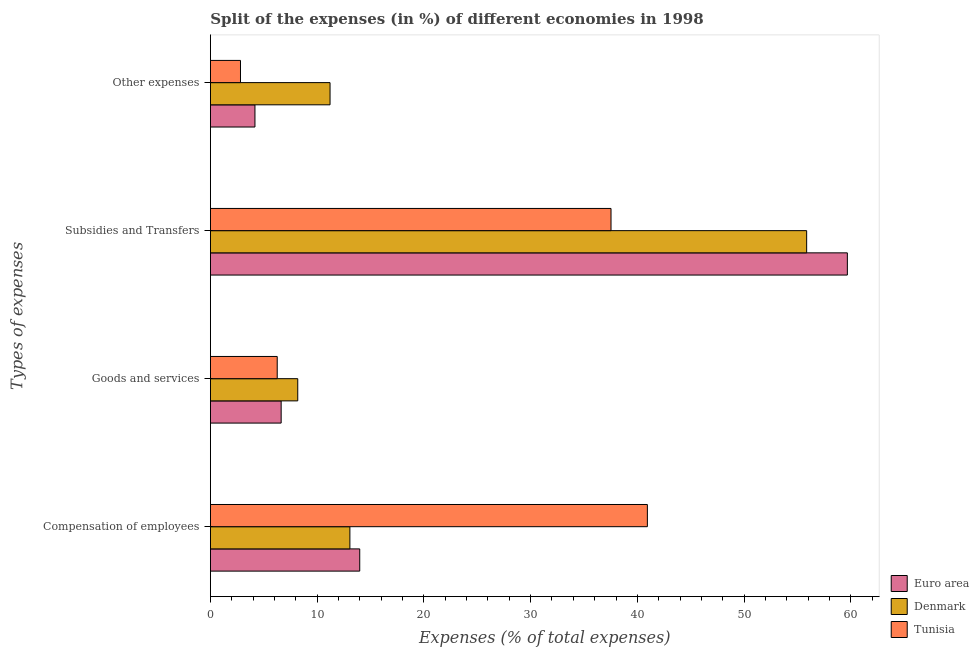How many different coloured bars are there?
Make the answer very short. 3. How many groups of bars are there?
Your answer should be compact. 4. Are the number of bars per tick equal to the number of legend labels?
Provide a short and direct response. Yes. Are the number of bars on each tick of the Y-axis equal?
Your response must be concise. Yes. How many bars are there on the 4th tick from the bottom?
Ensure brevity in your answer.  3. What is the label of the 4th group of bars from the top?
Provide a short and direct response. Compensation of employees. What is the percentage of amount spent on goods and services in Tunisia?
Offer a very short reply. 6.26. Across all countries, what is the maximum percentage of amount spent on subsidies?
Your response must be concise. 59.67. Across all countries, what is the minimum percentage of amount spent on other expenses?
Offer a very short reply. 2.82. In which country was the percentage of amount spent on goods and services maximum?
Your answer should be compact. Denmark. In which country was the percentage of amount spent on goods and services minimum?
Make the answer very short. Tunisia. What is the total percentage of amount spent on other expenses in the graph?
Your answer should be compact. 18.21. What is the difference between the percentage of amount spent on goods and services in Tunisia and that in Euro area?
Your answer should be compact. -0.37. What is the difference between the percentage of amount spent on compensation of employees in Tunisia and the percentage of amount spent on goods and services in Denmark?
Offer a very short reply. 32.75. What is the average percentage of amount spent on goods and services per country?
Make the answer very short. 7.03. What is the difference between the percentage of amount spent on subsidies and percentage of amount spent on goods and services in Tunisia?
Offer a terse response. 31.27. In how many countries, is the percentage of amount spent on goods and services greater than 30 %?
Provide a succinct answer. 0. What is the ratio of the percentage of amount spent on subsidies in Tunisia to that in Denmark?
Offer a very short reply. 0.67. What is the difference between the highest and the second highest percentage of amount spent on subsidies?
Give a very brief answer. 3.81. What is the difference between the highest and the lowest percentage of amount spent on compensation of employees?
Your response must be concise. 27.87. In how many countries, is the percentage of amount spent on compensation of employees greater than the average percentage of amount spent on compensation of employees taken over all countries?
Provide a short and direct response. 1. Is the sum of the percentage of amount spent on goods and services in Tunisia and Euro area greater than the maximum percentage of amount spent on subsidies across all countries?
Offer a terse response. No. What does the 1st bar from the top in Subsidies and Transfers represents?
Give a very brief answer. Tunisia. What does the 1st bar from the bottom in Goods and services represents?
Ensure brevity in your answer.  Euro area. Are all the bars in the graph horizontal?
Keep it short and to the point. Yes. Are the values on the major ticks of X-axis written in scientific E-notation?
Your answer should be compact. No. Where does the legend appear in the graph?
Offer a very short reply. Bottom right. How many legend labels are there?
Provide a short and direct response. 3. What is the title of the graph?
Offer a terse response. Split of the expenses (in %) of different economies in 1998. Does "Malawi" appear as one of the legend labels in the graph?
Provide a short and direct response. No. What is the label or title of the X-axis?
Give a very brief answer. Expenses (% of total expenses). What is the label or title of the Y-axis?
Give a very brief answer. Types of expenses. What is the Expenses (% of total expenses) of Euro area in Compensation of employees?
Ensure brevity in your answer.  13.99. What is the Expenses (% of total expenses) of Denmark in Compensation of employees?
Provide a short and direct response. 13.07. What is the Expenses (% of total expenses) in Tunisia in Compensation of employees?
Offer a very short reply. 40.94. What is the Expenses (% of total expenses) of Euro area in Goods and services?
Provide a succinct answer. 6.63. What is the Expenses (% of total expenses) in Denmark in Goods and services?
Provide a succinct answer. 8.18. What is the Expenses (% of total expenses) of Tunisia in Goods and services?
Your response must be concise. 6.26. What is the Expenses (% of total expenses) of Euro area in Subsidies and Transfers?
Your answer should be very brief. 59.67. What is the Expenses (% of total expenses) of Denmark in Subsidies and Transfers?
Your answer should be very brief. 55.86. What is the Expenses (% of total expenses) of Tunisia in Subsidies and Transfers?
Ensure brevity in your answer.  37.53. What is the Expenses (% of total expenses) in Euro area in Other expenses?
Make the answer very short. 4.18. What is the Expenses (% of total expenses) in Denmark in Other expenses?
Your response must be concise. 11.21. What is the Expenses (% of total expenses) in Tunisia in Other expenses?
Your response must be concise. 2.82. Across all Types of expenses, what is the maximum Expenses (% of total expenses) in Euro area?
Keep it short and to the point. 59.67. Across all Types of expenses, what is the maximum Expenses (% of total expenses) in Denmark?
Give a very brief answer. 55.86. Across all Types of expenses, what is the maximum Expenses (% of total expenses) in Tunisia?
Ensure brevity in your answer.  40.94. Across all Types of expenses, what is the minimum Expenses (% of total expenses) in Euro area?
Ensure brevity in your answer.  4.18. Across all Types of expenses, what is the minimum Expenses (% of total expenses) in Denmark?
Keep it short and to the point. 8.18. Across all Types of expenses, what is the minimum Expenses (% of total expenses) in Tunisia?
Provide a succinct answer. 2.82. What is the total Expenses (% of total expenses) in Euro area in the graph?
Keep it short and to the point. 84.47. What is the total Expenses (% of total expenses) in Denmark in the graph?
Give a very brief answer. 88.32. What is the total Expenses (% of total expenses) in Tunisia in the graph?
Your answer should be compact. 87.55. What is the difference between the Expenses (% of total expenses) in Euro area in Compensation of employees and that in Goods and services?
Provide a short and direct response. 7.36. What is the difference between the Expenses (% of total expenses) in Denmark in Compensation of employees and that in Goods and services?
Your response must be concise. 4.88. What is the difference between the Expenses (% of total expenses) in Tunisia in Compensation of employees and that in Goods and services?
Offer a terse response. 34.68. What is the difference between the Expenses (% of total expenses) of Euro area in Compensation of employees and that in Subsidies and Transfers?
Provide a short and direct response. -45.68. What is the difference between the Expenses (% of total expenses) in Denmark in Compensation of employees and that in Subsidies and Transfers?
Your answer should be very brief. -42.79. What is the difference between the Expenses (% of total expenses) of Tunisia in Compensation of employees and that in Subsidies and Transfers?
Keep it short and to the point. 3.41. What is the difference between the Expenses (% of total expenses) in Euro area in Compensation of employees and that in Other expenses?
Offer a terse response. 9.82. What is the difference between the Expenses (% of total expenses) in Denmark in Compensation of employees and that in Other expenses?
Offer a terse response. 1.86. What is the difference between the Expenses (% of total expenses) in Tunisia in Compensation of employees and that in Other expenses?
Give a very brief answer. 38.12. What is the difference between the Expenses (% of total expenses) in Euro area in Goods and services and that in Subsidies and Transfers?
Keep it short and to the point. -53.04. What is the difference between the Expenses (% of total expenses) of Denmark in Goods and services and that in Subsidies and Transfers?
Offer a very short reply. -47.68. What is the difference between the Expenses (% of total expenses) in Tunisia in Goods and services and that in Subsidies and Transfers?
Provide a succinct answer. -31.27. What is the difference between the Expenses (% of total expenses) in Euro area in Goods and services and that in Other expenses?
Offer a terse response. 2.45. What is the difference between the Expenses (% of total expenses) of Denmark in Goods and services and that in Other expenses?
Give a very brief answer. -3.03. What is the difference between the Expenses (% of total expenses) of Tunisia in Goods and services and that in Other expenses?
Ensure brevity in your answer.  3.44. What is the difference between the Expenses (% of total expenses) in Euro area in Subsidies and Transfers and that in Other expenses?
Your answer should be very brief. 55.5. What is the difference between the Expenses (% of total expenses) of Denmark in Subsidies and Transfers and that in Other expenses?
Make the answer very short. 44.65. What is the difference between the Expenses (% of total expenses) of Tunisia in Subsidies and Transfers and that in Other expenses?
Ensure brevity in your answer.  34.71. What is the difference between the Expenses (% of total expenses) in Euro area in Compensation of employees and the Expenses (% of total expenses) in Denmark in Goods and services?
Offer a terse response. 5.81. What is the difference between the Expenses (% of total expenses) of Euro area in Compensation of employees and the Expenses (% of total expenses) of Tunisia in Goods and services?
Your answer should be compact. 7.73. What is the difference between the Expenses (% of total expenses) in Denmark in Compensation of employees and the Expenses (% of total expenses) in Tunisia in Goods and services?
Offer a terse response. 6.81. What is the difference between the Expenses (% of total expenses) of Euro area in Compensation of employees and the Expenses (% of total expenses) of Denmark in Subsidies and Transfers?
Your response must be concise. -41.87. What is the difference between the Expenses (% of total expenses) in Euro area in Compensation of employees and the Expenses (% of total expenses) in Tunisia in Subsidies and Transfers?
Your answer should be very brief. -23.54. What is the difference between the Expenses (% of total expenses) of Denmark in Compensation of employees and the Expenses (% of total expenses) of Tunisia in Subsidies and Transfers?
Your response must be concise. -24.46. What is the difference between the Expenses (% of total expenses) in Euro area in Compensation of employees and the Expenses (% of total expenses) in Denmark in Other expenses?
Your answer should be compact. 2.78. What is the difference between the Expenses (% of total expenses) of Euro area in Compensation of employees and the Expenses (% of total expenses) of Tunisia in Other expenses?
Keep it short and to the point. 11.17. What is the difference between the Expenses (% of total expenses) of Denmark in Compensation of employees and the Expenses (% of total expenses) of Tunisia in Other expenses?
Give a very brief answer. 10.25. What is the difference between the Expenses (% of total expenses) in Euro area in Goods and services and the Expenses (% of total expenses) in Denmark in Subsidies and Transfers?
Offer a very short reply. -49.23. What is the difference between the Expenses (% of total expenses) in Euro area in Goods and services and the Expenses (% of total expenses) in Tunisia in Subsidies and Transfers?
Offer a very short reply. -30.9. What is the difference between the Expenses (% of total expenses) of Denmark in Goods and services and the Expenses (% of total expenses) of Tunisia in Subsidies and Transfers?
Your answer should be compact. -29.35. What is the difference between the Expenses (% of total expenses) of Euro area in Goods and services and the Expenses (% of total expenses) of Denmark in Other expenses?
Give a very brief answer. -4.58. What is the difference between the Expenses (% of total expenses) of Euro area in Goods and services and the Expenses (% of total expenses) of Tunisia in Other expenses?
Keep it short and to the point. 3.81. What is the difference between the Expenses (% of total expenses) in Denmark in Goods and services and the Expenses (% of total expenses) in Tunisia in Other expenses?
Your response must be concise. 5.37. What is the difference between the Expenses (% of total expenses) of Euro area in Subsidies and Transfers and the Expenses (% of total expenses) of Denmark in Other expenses?
Keep it short and to the point. 48.46. What is the difference between the Expenses (% of total expenses) of Euro area in Subsidies and Transfers and the Expenses (% of total expenses) of Tunisia in Other expenses?
Keep it short and to the point. 56.85. What is the difference between the Expenses (% of total expenses) in Denmark in Subsidies and Transfers and the Expenses (% of total expenses) in Tunisia in Other expenses?
Keep it short and to the point. 53.04. What is the average Expenses (% of total expenses) in Euro area per Types of expenses?
Provide a succinct answer. 21.12. What is the average Expenses (% of total expenses) of Denmark per Types of expenses?
Offer a terse response. 22.08. What is the average Expenses (% of total expenses) in Tunisia per Types of expenses?
Give a very brief answer. 21.89. What is the difference between the Expenses (% of total expenses) in Euro area and Expenses (% of total expenses) in Denmark in Compensation of employees?
Your answer should be compact. 0.92. What is the difference between the Expenses (% of total expenses) of Euro area and Expenses (% of total expenses) of Tunisia in Compensation of employees?
Ensure brevity in your answer.  -26.95. What is the difference between the Expenses (% of total expenses) of Denmark and Expenses (% of total expenses) of Tunisia in Compensation of employees?
Give a very brief answer. -27.87. What is the difference between the Expenses (% of total expenses) in Euro area and Expenses (% of total expenses) in Denmark in Goods and services?
Provide a succinct answer. -1.55. What is the difference between the Expenses (% of total expenses) of Euro area and Expenses (% of total expenses) of Tunisia in Goods and services?
Your answer should be very brief. 0.37. What is the difference between the Expenses (% of total expenses) in Denmark and Expenses (% of total expenses) in Tunisia in Goods and services?
Provide a succinct answer. 1.92. What is the difference between the Expenses (% of total expenses) of Euro area and Expenses (% of total expenses) of Denmark in Subsidies and Transfers?
Provide a short and direct response. 3.81. What is the difference between the Expenses (% of total expenses) in Euro area and Expenses (% of total expenses) in Tunisia in Subsidies and Transfers?
Offer a terse response. 22.14. What is the difference between the Expenses (% of total expenses) of Denmark and Expenses (% of total expenses) of Tunisia in Subsidies and Transfers?
Your response must be concise. 18.33. What is the difference between the Expenses (% of total expenses) in Euro area and Expenses (% of total expenses) in Denmark in Other expenses?
Offer a very short reply. -7.03. What is the difference between the Expenses (% of total expenses) in Euro area and Expenses (% of total expenses) in Tunisia in Other expenses?
Ensure brevity in your answer.  1.36. What is the difference between the Expenses (% of total expenses) of Denmark and Expenses (% of total expenses) of Tunisia in Other expenses?
Your answer should be very brief. 8.39. What is the ratio of the Expenses (% of total expenses) of Euro area in Compensation of employees to that in Goods and services?
Ensure brevity in your answer.  2.11. What is the ratio of the Expenses (% of total expenses) of Denmark in Compensation of employees to that in Goods and services?
Give a very brief answer. 1.6. What is the ratio of the Expenses (% of total expenses) of Tunisia in Compensation of employees to that in Goods and services?
Your answer should be very brief. 6.54. What is the ratio of the Expenses (% of total expenses) in Euro area in Compensation of employees to that in Subsidies and Transfers?
Provide a short and direct response. 0.23. What is the ratio of the Expenses (% of total expenses) of Denmark in Compensation of employees to that in Subsidies and Transfers?
Your answer should be compact. 0.23. What is the ratio of the Expenses (% of total expenses) of Tunisia in Compensation of employees to that in Subsidies and Transfers?
Provide a succinct answer. 1.09. What is the ratio of the Expenses (% of total expenses) in Euro area in Compensation of employees to that in Other expenses?
Provide a succinct answer. 3.35. What is the ratio of the Expenses (% of total expenses) in Denmark in Compensation of employees to that in Other expenses?
Offer a very short reply. 1.17. What is the ratio of the Expenses (% of total expenses) of Tunisia in Compensation of employees to that in Other expenses?
Keep it short and to the point. 14.52. What is the ratio of the Expenses (% of total expenses) of Euro area in Goods and services to that in Subsidies and Transfers?
Offer a very short reply. 0.11. What is the ratio of the Expenses (% of total expenses) of Denmark in Goods and services to that in Subsidies and Transfers?
Offer a terse response. 0.15. What is the ratio of the Expenses (% of total expenses) of Tunisia in Goods and services to that in Subsidies and Transfers?
Your answer should be compact. 0.17. What is the ratio of the Expenses (% of total expenses) in Euro area in Goods and services to that in Other expenses?
Provide a short and direct response. 1.59. What is the ratio of the Expenses (% of total expenses) in Denmark in Goods and services to that in Other expenses?
Provide a short and direct response. 0.73. What is the ratio of the Expenses (% of total expenses) of Tunisia in Goods and services to that in Other expenses?
Offer a terse response. 2.22. What is the ratio of the Expenses (% of total expenses) in Euro area in Subsidies and Transfers to that in Other expenses?
Your answer should be compact. 14.29. What is the ratio of the Expenses (% of total expenses) of Denmark in Subsidies and Transfers to that in Other expenses?
Provide a succinct answer. 4.98. What is the ratio of the Expenses (% of total expenses) in Tunisia in Subsidies and Transfers to that in Other expenses?
Make the answer very short. 13.31. What is the difference between the highest and the second highest Expenses (% of total expenses) of Euro area?
Your answer should be very brief. 45.68. What is the difference between the highest and the second highest Expenses (% of total expenses) in Denmark?
Provide a succinct answer. 42.79. What is the difference between the highest and the second highest Expenses (% of total expenses) of Tunisia?
Your answer should be compact. 3.41. What is the difference between the highest and the lowest Expenses (% of total expenses) in Euro area?
Make the answer very short. 55.5. What is the difference between the highest and the lowest Expenses (% of total expenses) of Denmark?
Your response must be concise. 47.68. What is the difference between the highest and the lowest Expenses (% of total expenses) in Tunisia?
Ensure brevity in your answer.  38.12. 